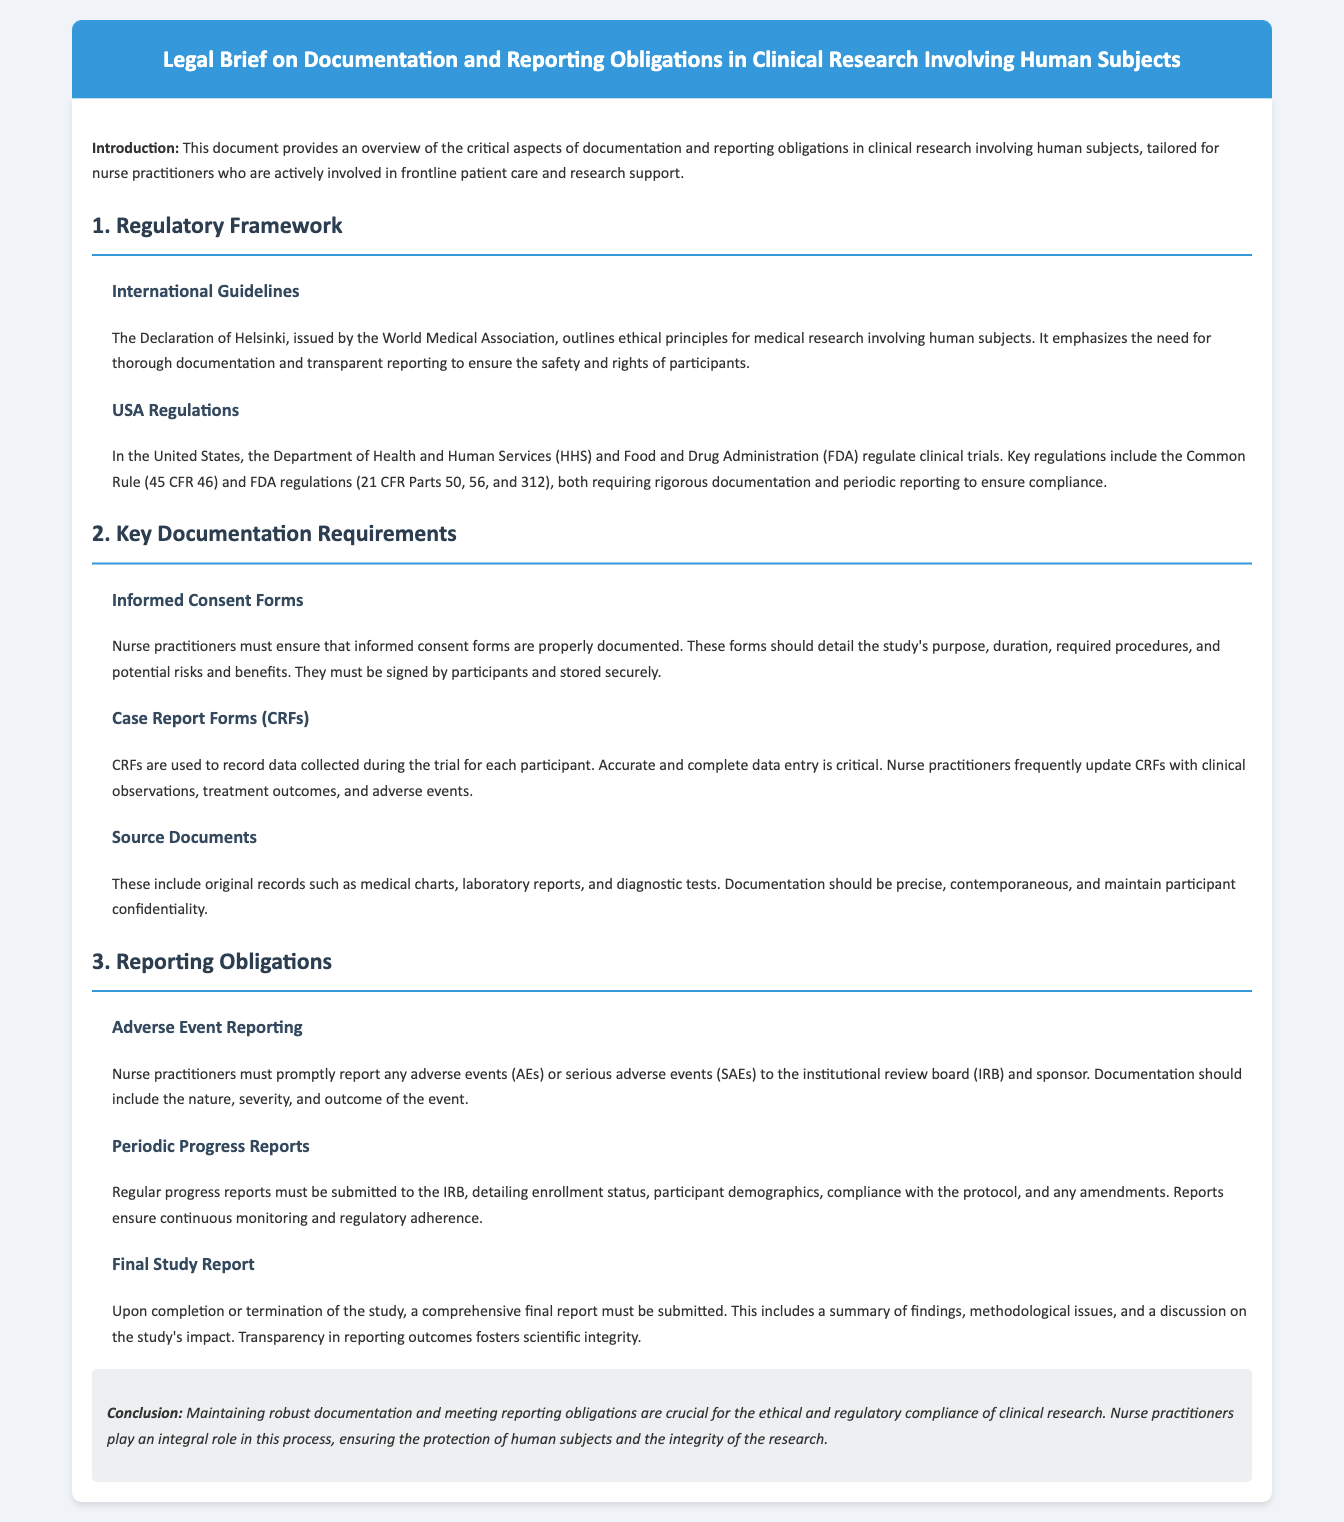What is the title of the document? The title is prominently displayed in the header of the document, which is "Legal Brief on Documentation and Reporting Obligations in Clinical Research Involving Human Subjects."
Answer: Legal Brief on Documentation and Reporting Obligations in Clinical Research Involving Human Subjects Who issues the Declaration of Helsinki? The Declaration of Helsinki is issued by the World Medical Association, as mentioned in the section on International Guidelines.
Answer: World Medical Association What are the key U.S. regulations mentioned? The document references the Common Rule (45 CFR 46) and FDA regulations (21 CFR Parts 50, 56, and 312) under the USA Regulations section.
Answer: Common Rule, FDA regulations What must informed consent forms detail? The informed consent forms must detail the study's purpose, duration, required procedures, and potential risks and benefits, as outlined in the Key Documentation Requirements section.
Answer: Purpose, duration, required procedures, risks and benefits What is required for adverse event reporting? The document states that nurse practitioners must promptly report any adverse events or serious adverse events to the institutional review board (IRB) and sponsor, detailing the nature, severity, and outcome of the event.
Answer: Prompt reporting of AEs and SAEs What is included in the final study report? The final study report must include a summary of findings, methodological issues, and a discussion on the study's impact, as indicated in the Reporting Obligations section.
Answer: Summary of findings, methodological issues, study's impact 